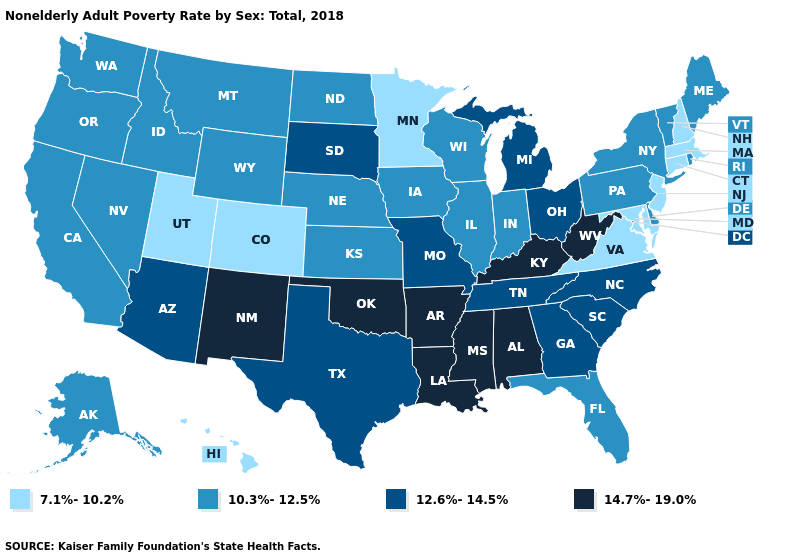Is the legend a continuous bar?
Quick response, please. No. Which states hav the highest value in the South?
Write a very short answer. Alabama, Arkansas, Kentucky, Louisiana, Mississippi, Oklahoma, West Virginia. How many symbols are there in the legend?
Give a very brief answer. 4. Is the legend a continuous bar?
Write a very short answer. No. Does the first symbol in the legend represent the smallest category?
Write a very short answer. Yes. Name the states that have a value in the range 7.1%-10.2%?
Short answer required. Colorado, Connecticut, Hawaii, Maryland, Massachusetts, Minnesota, New Hampshire, New Jersey, Utah, Virginia. Does Hawaii have the highest value in the West?
Be succinct. No. Name the states that have a value in the range 10.3%-12.5%?
Answer briefly. Alaska, California, Delaware, Florida, Idaho, Illinois, Indiana, Iowa, Kansas, Maine, Montana, Nebraska, Nevada, New York, North Dakota, Oregon, Pennsylvania, Rhode Island, Vermont, Washington, Wisconsin, Wyoming. Does North Carolina have a lower value than Oklahoma?
Write a very short answer. Yes. Does Illinois have the highest value in the USA?
Quick response, please. No. What is the value of Maryland?
Be succinct. 7.1%-10.2%. What is the highest value in the USA?
Quick response, please. 14.7%-19.0%. Name the states that have a value in the range 10.3%-12.5%?
Be succinct. Alaska, California, Delaware, Florida, Idaho, Illinois, Indiana, Iowa, Kansas, Maine, Montana, Nebraska, Nevada, New York, North Dakota, Oregon, Pennsylvania, Rhode Island, Vermont, Washington, Wisconsin, Wyoming. What is the highest value in the USA?
Short answer required. 14.7%-19.0%. Name the states that have a value in the range 10.3%-12.5%?
Concise answer only. Alaska, California, Delaware, Florida, Idaho, Illinois, Indiana, Iowa, Kansas, Maine, Montana, Nebraska, Nevada, New York, North Dakota, Oregon, Pennsylvania, Rhode Island, Vermont, Washington, Wisconsin, Wyoming. 